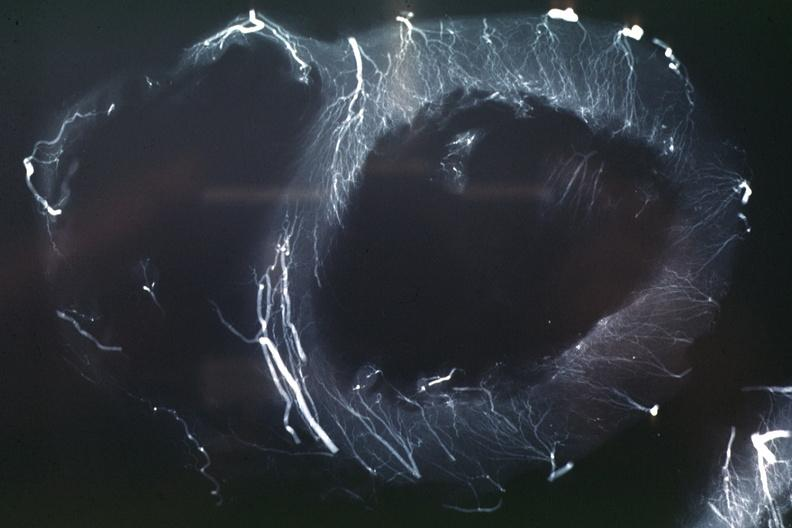s cardiovascular present?
Answer the question using a single word or phrase. Yes 